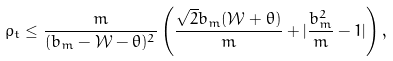<formula> <loc_0><loc_0><loc_500><loc_500>\rho _ { t } \leq \frac { m } { ( b _ { m } - \mathcal { W } - \theta ) ^ { 2 } } \left ( \frac { \sqrt { 2 } b _ { m } ( \mathcal { W } + \theta ) } { m } + | \frac { b _ { m } ^ { 2 } } { m } - 1 | \right ) ,</formula> 